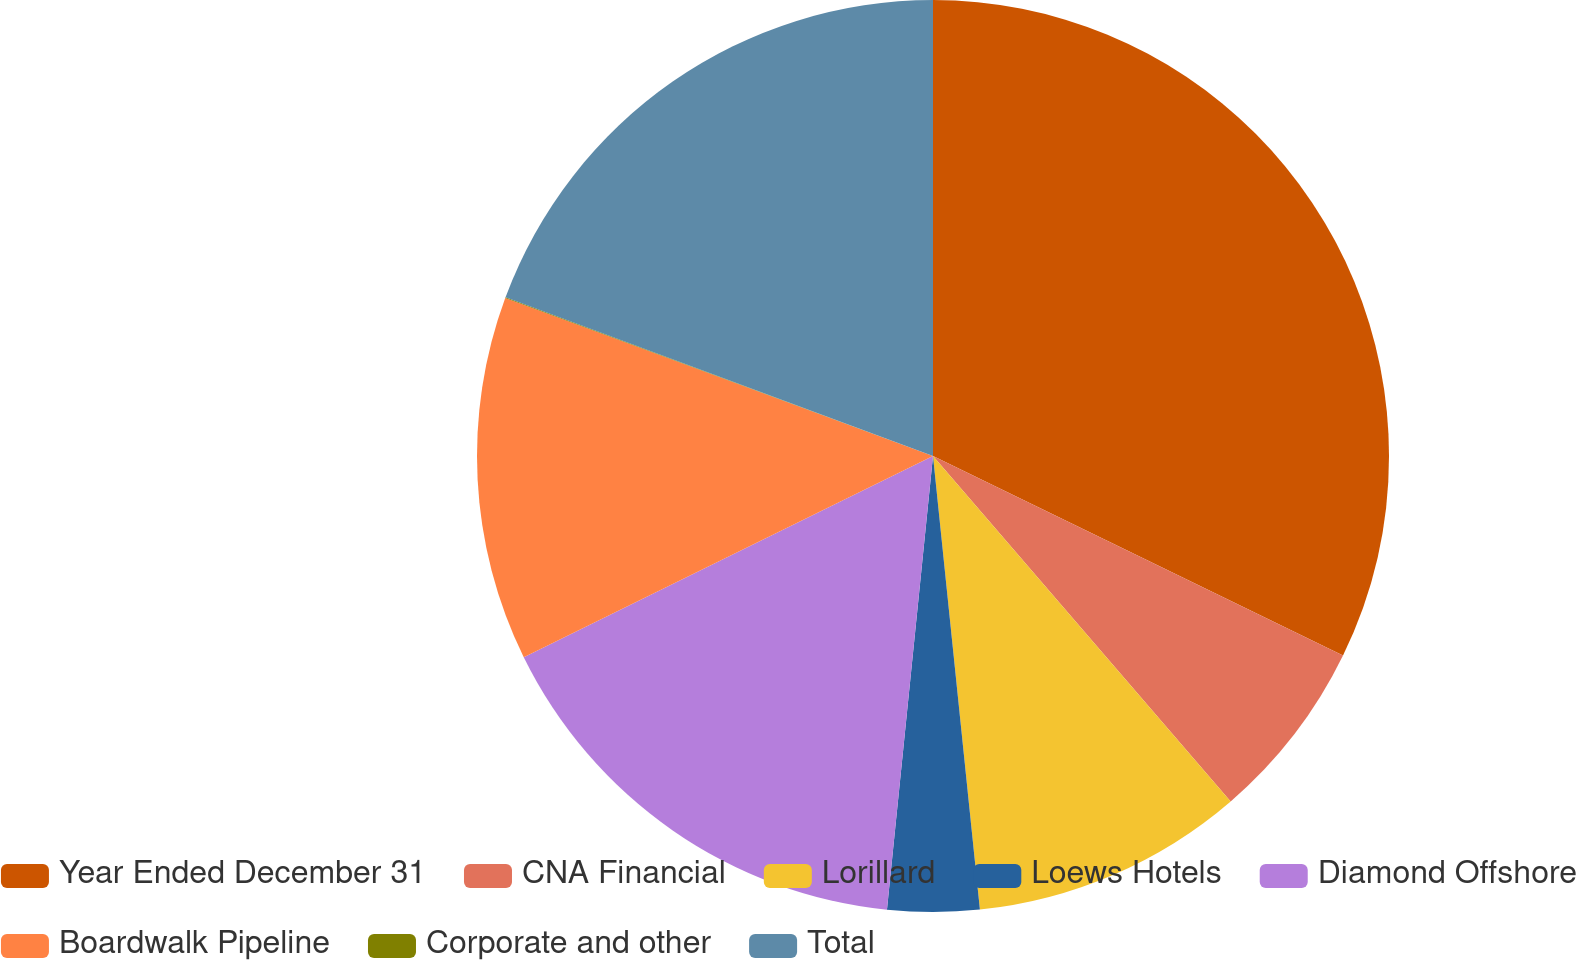<chart> <loc_0><loc_0><loc_500><loc_500><pie_chart><fcel>Year Ended December 31<fcel>CNA Financial<fcel>Lorillard<fcel>Loews Hotels<fcel>Diamond Offshore<fcel>Boardwalk Pipeline<fcel>Corporate and other<fcel>Total<nl><fcel>32.21%<fcel>6.47%<fcel>9.68%<fcel>3.25%<fcel>16.12%<fcel>12.9%<fcel>0.03%<fcel>19.34%<nl></chart> 